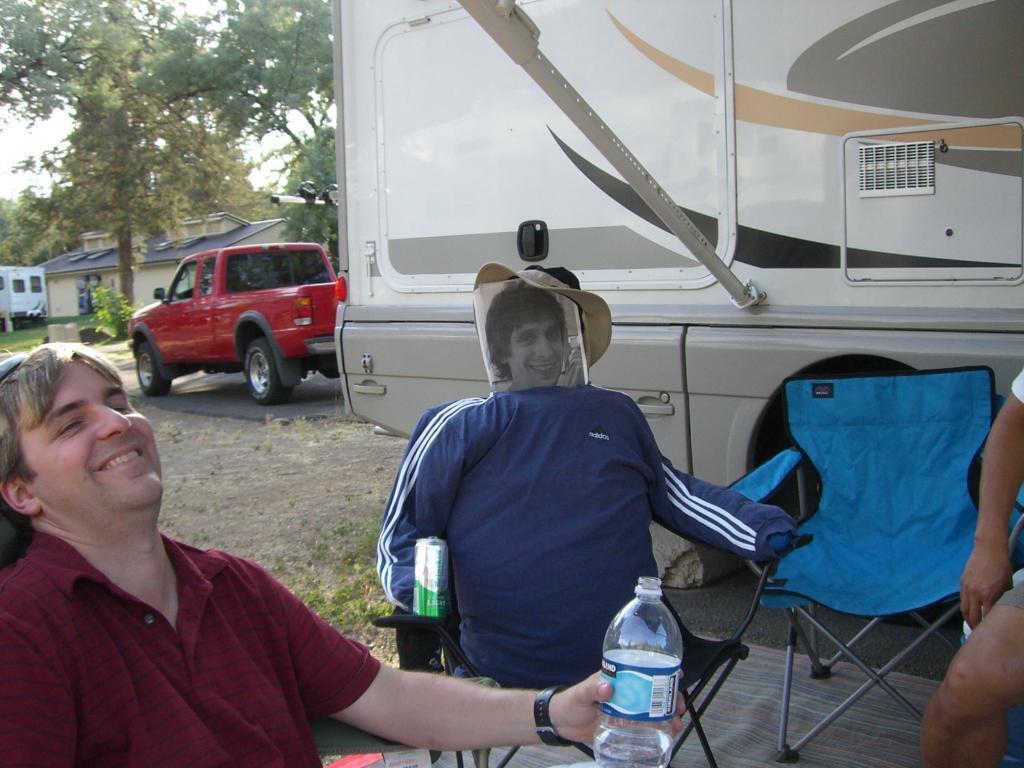How would you summarize this image in a sentence or two? Here we can see a man is sitting on the chair and smiling, and holding a water bottle in his hands, and at side here is the vehicle on the road, and here are the trees. 